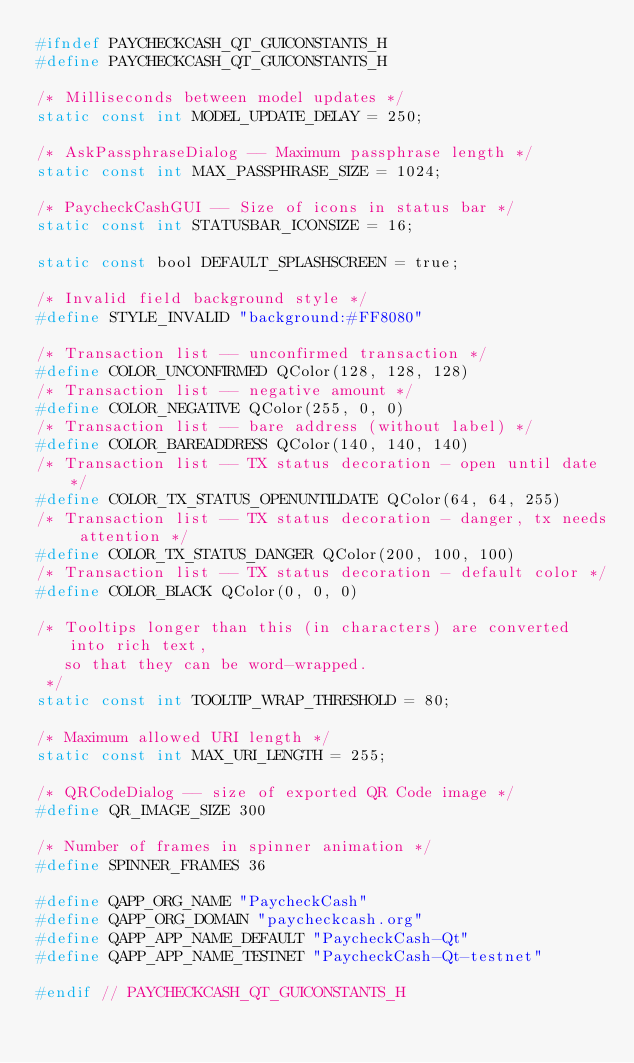<code> <loc_0><loc_0><loc_500><loc_500><_C_>#ifndef PAYCHECKCASH_QT_GUICONSTANTS_H
#define PAYCHECKCASH_QT_GUICONSTANTS_H

/* Milliseconds between model updates */
static const int MODEL_UPDATE_DELAY = 250;

/* AskPassphraseDialog -- Maximum passphrase length */
static const int MAX_PASSPHRASE_SIZE = 1024;

/* PaycheckCashGUI -- Size of icons in status bar */
static const int STATUSBAR_ICONSIZE = 16;

static const bool DEFAULT_SPLASHSCREEN = true;

/* Invalid field background style */
#define STYLE_INVALID "background:#FF8080"

/* Transaction list -- unconfirmed transaction */
#define COLOR_UNCONFIRMED QColor(128, 128, 128)
/* Transaction list -- negative amount */
#define COLOR_NEGATIVE QColor(255, 0, 0)
/* Transaction list -- bare address (without label) */
#define COLOR_BAREADDRESS QColor(140, 140, 140)
/* Transaction list -- TX status decoration - open until date */
#define COLOR_TX_STATUS_OPENUNTILDATE QColor(64, 64, 255)
/* Transaction list -- TX status decoration - danger, tx needs attention */
#define COLOR_TX_STATUS_DANGER QColor(200, 100, 100)
/* Transaction list -- TX status decoration - default color */
#define COLOR_BLACK QColor(0, 0, 0)

/* Tooltips longer than this (in characters) are converted into rich text,
   so that they can be word-wrapped.
 */
static const int TOOLTIP_WRAP_THRESHOLD = 80;

/* Maximum allowed URI length */
static const int MAX_URI_LENGTH = 255;

/* QRCodeDialog -- size of exported QR Code image */
#define QR_IMAGE_SIZE 300

/* Number of frames in spinner animation */
#define SPINNER_FRAMES 36

#define QAPP_ORG_NAME "PaycheckCash"
#define QAPP_ORG_DOMAIN "paycheckcash.org"
#define QAPP_APP_NAME_DEFAULT "PaycheckCash-Qt"
#define QAPP_APP_NAME_TESTNET "PaycheckCash-Qt-testnet"

#endif // PAYCHECKCASH_QT_GUICONSTANTS_H
</code> 